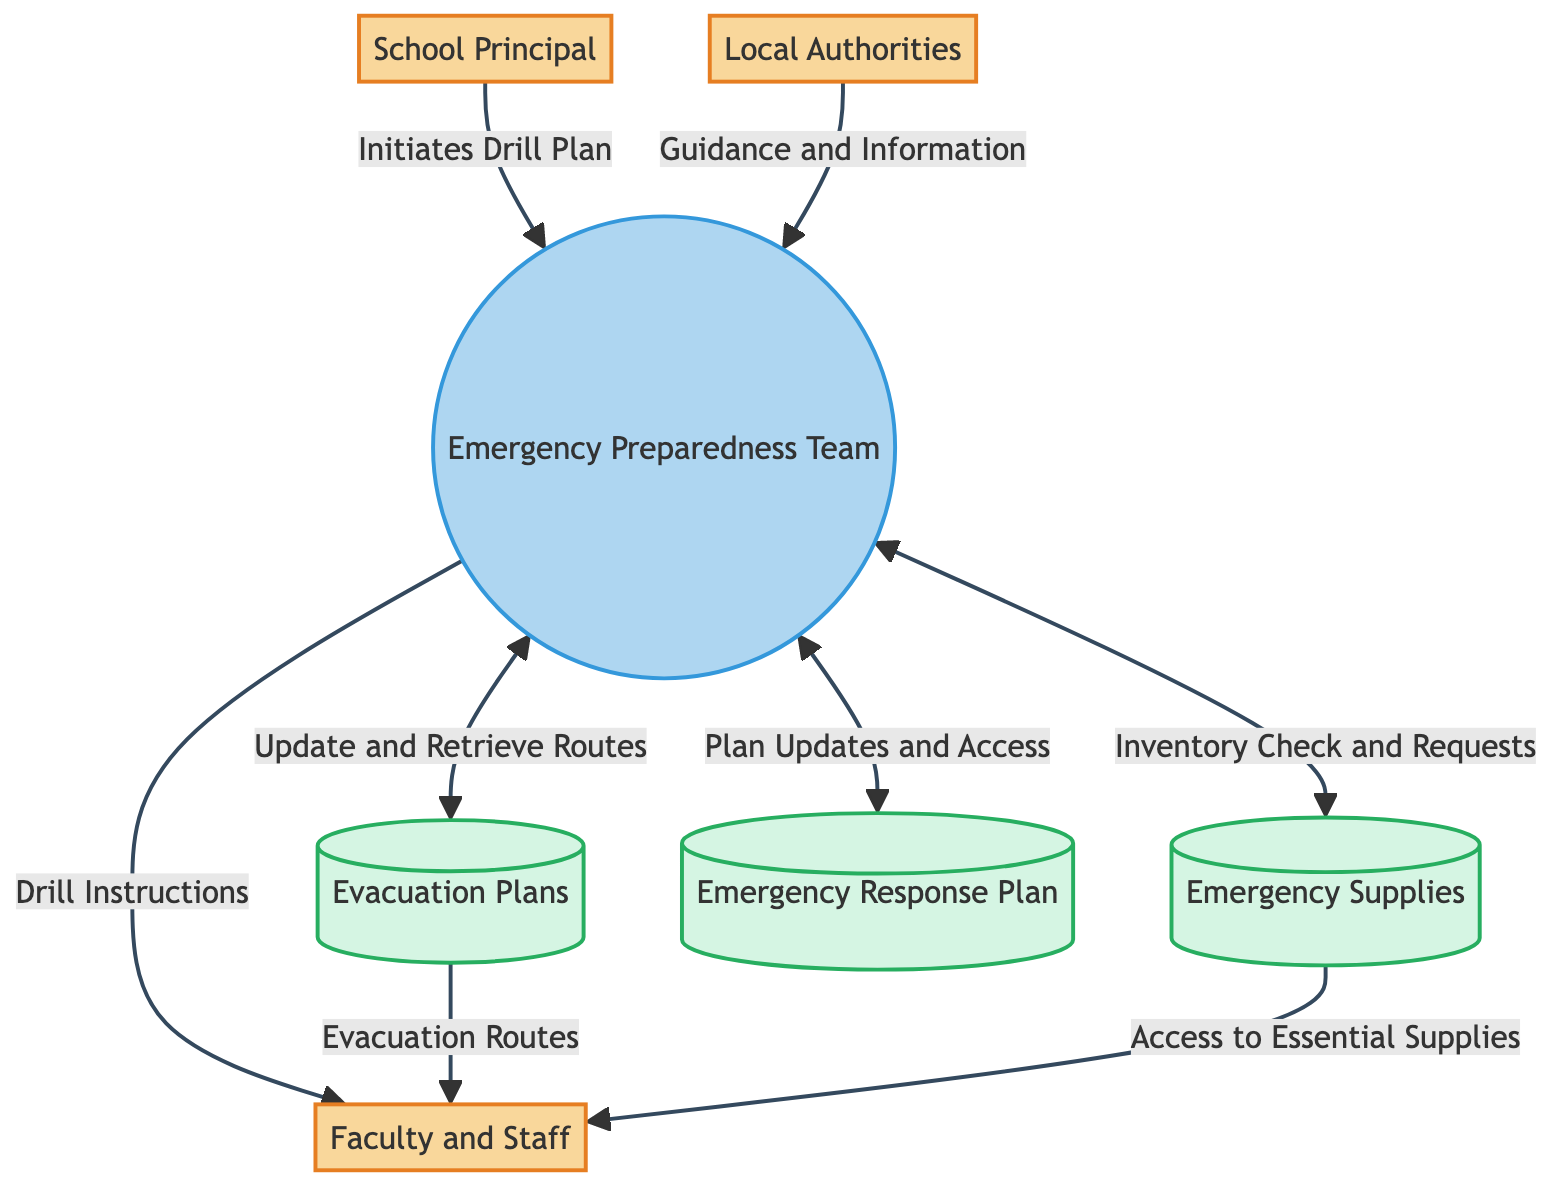What's the role of the School Principal? The School Principal is an external entity that initiates emergency drills and oversees the emergency preparedness plan, which is indicated by the description in the diagram.
Answer: Initiates emergency drills and oversees the emergency preparedness plan How many external entities are in the diagram? The diagram identifies four external entities: School Principal, Faculty and Staff, Local Authorities, and Emergency Preparedness Team, so counting these gives a total of four.
Answer: Four What does the Emergency Preparedness Team provide to Faculty and Staff? The Emergency Preparedness Team sends Drill Instructions to Faculty and Staff, which is shown by the directed arrow from Emergency Preparedness Team to Faculty and Staff labeled with this specific data.
Answer: Drill Instructions Which data store receives updates from the Emergency Preparedness Team? The Emergency Response Plan receives Plan Updates and Access from the Emergency Preparedness Team, as indicated by the flow labeled with this data moving towards the Emergency Response Plan.
Answer: Emergency Response Plan How many data flows originate from the Emergency Preparedness Team? The Emergency Preparedness Team has five outgoing data flows to other entities and data stores in the diagram, as counted from the arrows pointing away from it.
Answer: Five What type of entity is the Local Authorities? The Local Authorities are described as an external entity in the diagram, which is reflected in its classification with a different fill color and the external entity label.
Answer: External entity What data is provided by Local Authorities to the Emergency Preparedness Team? Local Authorities provide Guidance and Information to the Emergency Preparedness Team, as depicted in the diagram by the flow labeled with these words directed from Local Authorities to Emergency Preparedness Team.
Answer: Guidance and Information Which data store contains Evacuation Routes? The Evacuation Plans data store contains Evacuation Routes, as indicated by the flow arrow directing this information from Evacuation Plans to Faculty and Staff in the diagram.
Answer: Evacuation Plans What does the Emergency Supplies data store provide to Faculty and Staff? The Emergency Supplies data store provides Access to Essential Supplies to Faculty and Staff, as evidenced by the directed flow labeled with this data in the diagram.
Answer: Access to Essential Supplies 